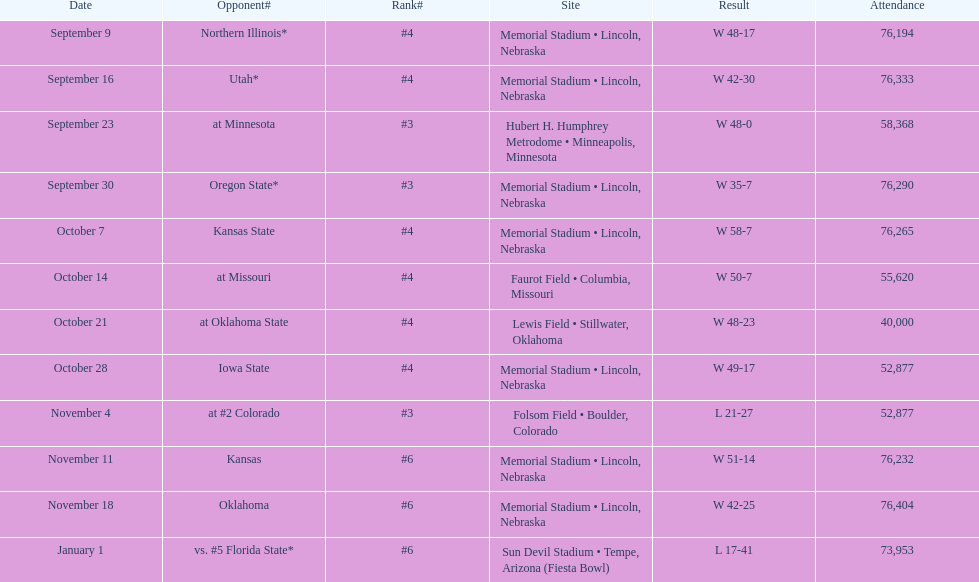Would you be able to parse every entry in this table? {'header': ['Date', 'Opponent#', 'Rank#', 'Site', 'Result', 'Attendance'], 'rows': [['September 9', 'Northern Illinois*', '#4', 'Memorial Stadium • Lincoln, Nebraska', 'W\xa048-17', '76,194'], ['September 16', 'Utah*', '#4', 'Memorial Stadium • Lincoln, Nebraska', 'W\xa042-30', '76,333'], ['September 23', 'at\xa0Minnesota', '#3', 'Hubert H. Humphrey Metrodome • Minneapolis, Minnesota', 'W\xa048-0', '58,368'], ['September 30', 'Oregon State*', '#3', 'Memorial Stadium • Lincoln, Nebraska', 'W\xa035-7', '76,290'], ['October 7', 'Kansas State', '#4', 'Memorial Stadium • Lincoln, Nebraska', 'W\xa058-7', '76,265'], ['October 14', 'at\xa0Missouri', '#4', 'Faurot Field • Columbia, Missouri', 'W\xa050-7', '55,620'], ['October 21', 'at\xa0Oklahoma State', '#4', 'Lewis Field • Stillwater, Oklahoma', 'W\xa048-23', '40,000'], ['October 28', 'Iowa State', '#4', 'Memorial Stadium • Lincoln, Nebraska', 'W\xa049-17', '52,877'], ['November 4', 'at\xa0#2\xa0Colorado', '#3', 'Folsom Field • Boulder, Colorado', 'L\xa021-27', '52,877'], ['November 11', 'Kansas', '#6', 'Memorial Stadium • Lincoln, Nebraska', 'W\xa051-14', '76,232'], ['November 18', 'Oklahoma', '#6', 'Memorial Stadium • Lincoln, Nebraska', 'W\xa042-25', '76,404'], ['January 1', 'vs.\xa0#5\xa0Florida State*', '#6', 'Sun Devil Stadium • Tempe, Arizona (Fiesta Bowl)', 'L\xa017-41', '73,953']]} What site at most is taken place? Memorial Stadium • Lincoln, Nebraska. 